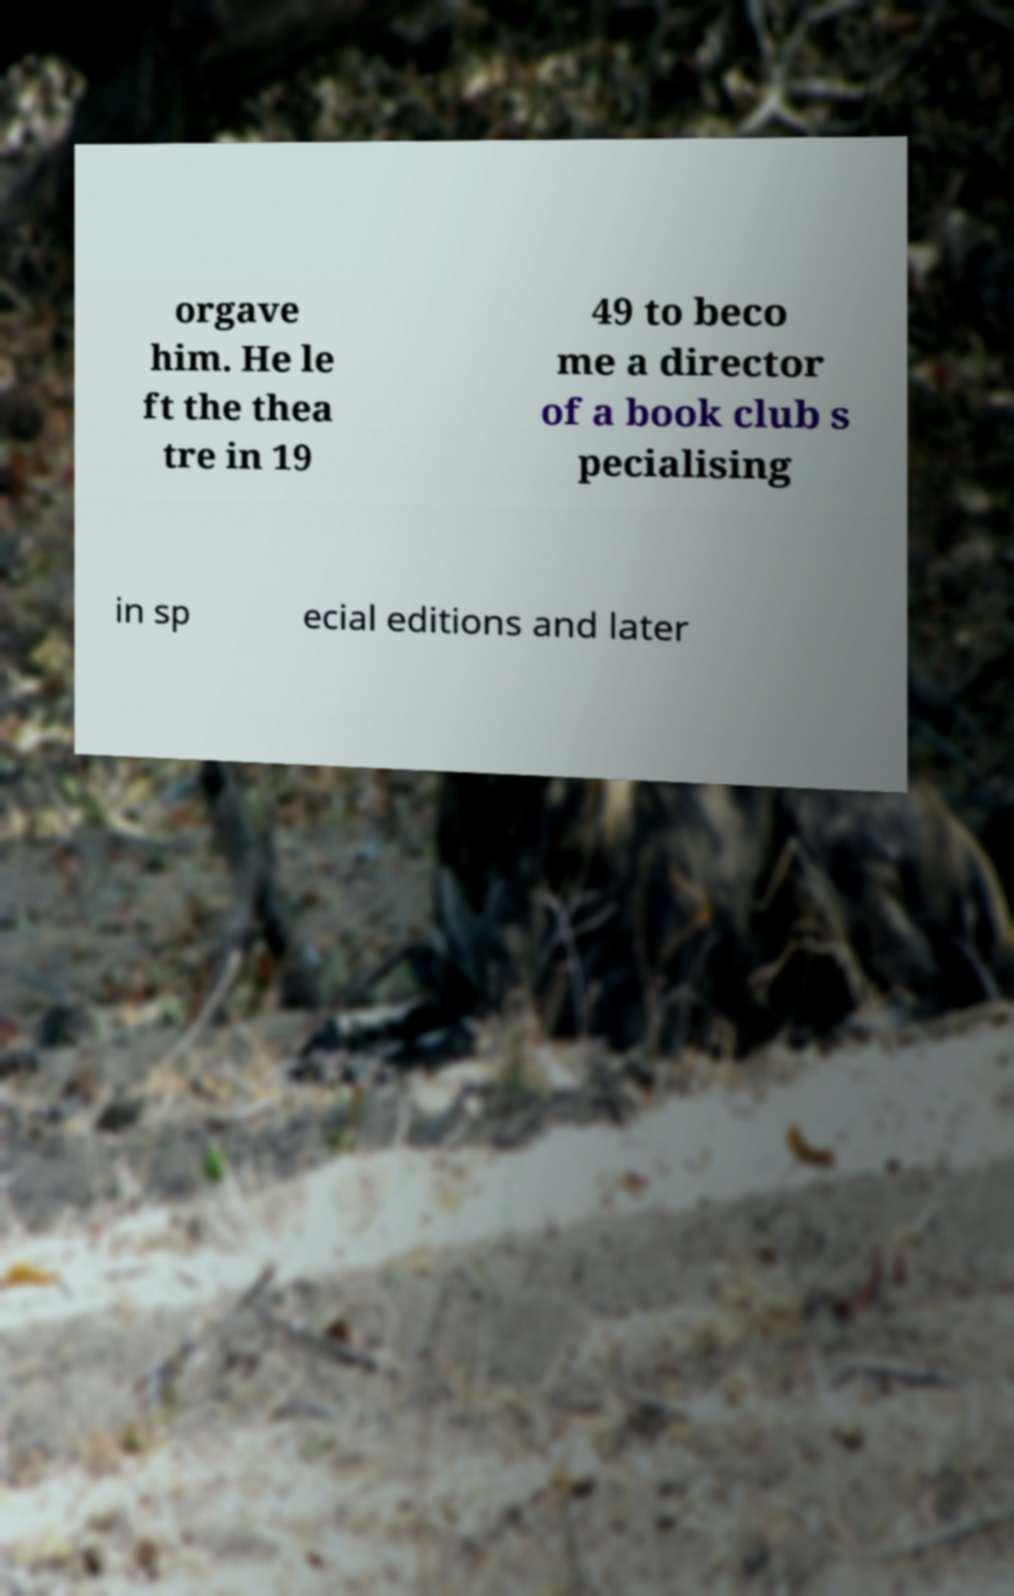Can you accurately transcribe the text from the provided image for me? orgave him. He le ft the thea tre in 19 49 to beco me a director of a book club s pecialising in sp ecial editions and later 